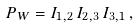<formula> <loc_0><loc_0><loc_500><loc_500>P _ { W } = I _ { 1 , 2 } \, I _ { 2 , 3 } \, I _ { 3 , 1 } \, ,</formula> 